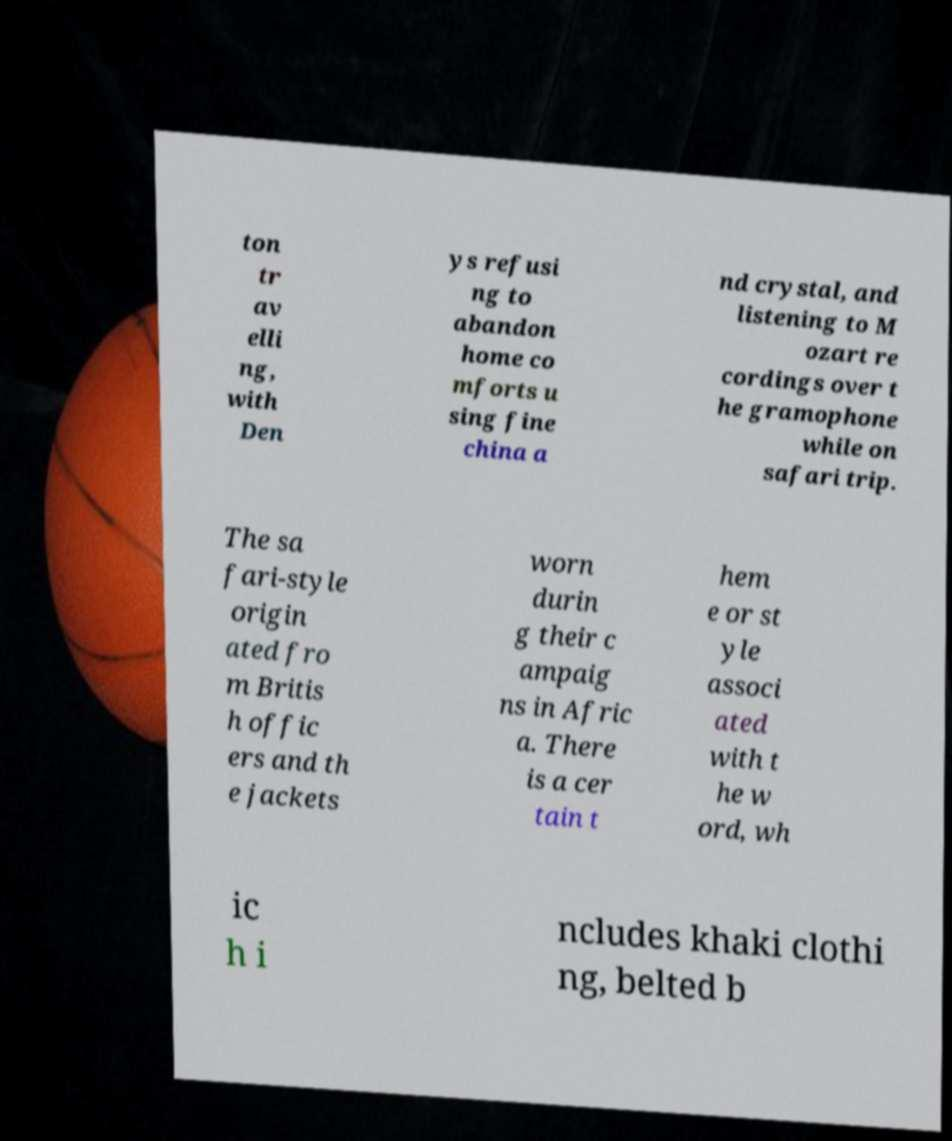Please identify and transcribe the text found in this image. ton tr av elli ng, with Den ys refusi ng to abandon home co mforts u sing fine china a nd crystal, and listening to M ozart re cordings over t he gramophone while on safari trip. The sa fari-style origin ated fro m Britis h offic ers and th e jackets worn durin g their c ampaig ns in Afric a. There is a cer tain t hem e or st yle associ ated with t he w ord, wh ic h i ncludes khaki clothi ng, belted b 